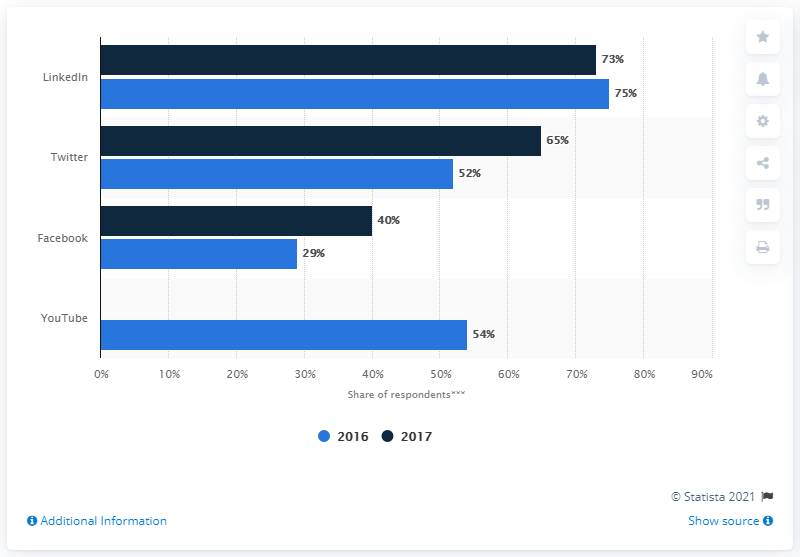Mention a couple of crucial points in this snapshot. In 2016, LinkedIn was found to have a 75% effectiveness in achieving business marketing goals. As of 2016, marketers had already begun using Twitter as a platform for content marketing. LinkedIn is the social media platform with the minimum difference in effectiveness. 